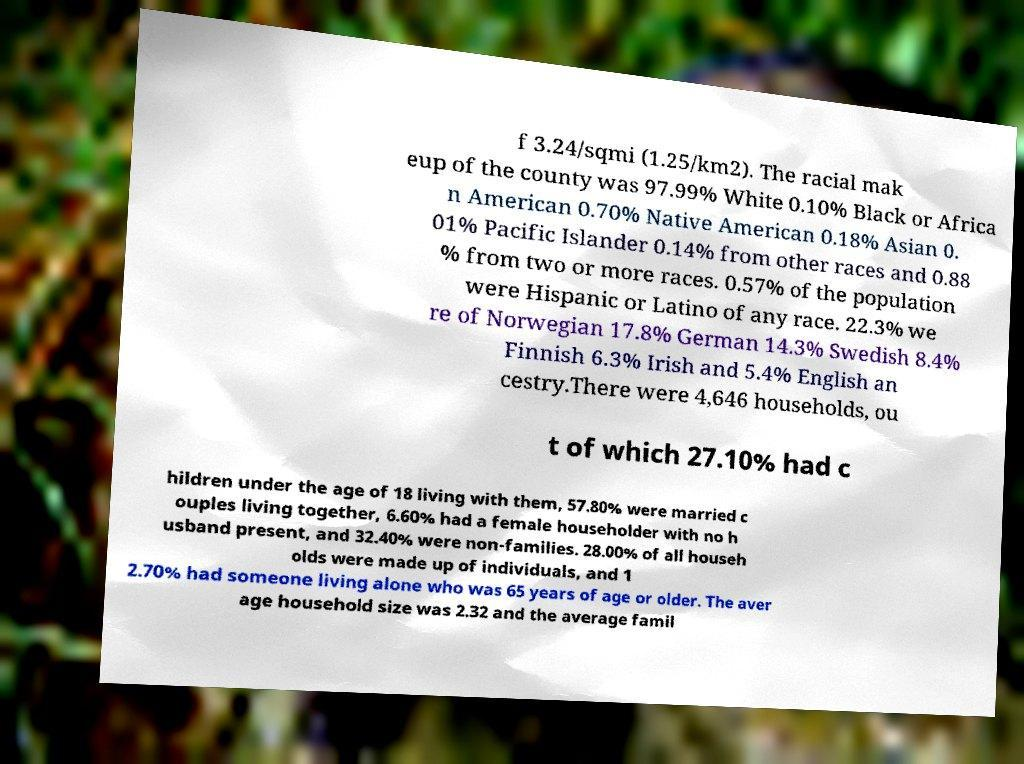For documentation purposes, I need the text within this image transcribed. Could you provide that? f 3.24/sqmi (1.25/km2). The racial mak eup of the county was 97.99% White 0.10% Black or Africa n American 0.70% Native American 0.18% Asian 0. 01% Pacific Islander 0.14% from other races and 0.88 % from two or more races. 0.57% of the population were Hispanic or Latino of any race. 22.3% we re of Norwegian 17.8% German 14.3% Swedish 8.4% Finnish 6.3% Irish and 5.4% English an cestry.There were 4,646 households, ou t of which 27.10% had c hildren under the age of 18 living with them, 57.80% were married c ouples living together, 6.60% had a female householder with no h usband present, and 32.40% were non-families. 28.00% of all househ olds were made up of individuals, and 1 2.70% had someone living alone who was 65 years of age or older. The aver age household size was 2.32 and the average famil 